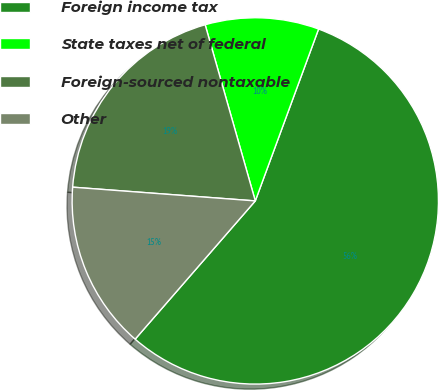Convert chart. <chart><loc_0><loc_0><loc_500><loc_500><pie_chart><fcel>Foreign income tax<fcel>State taxes net of federal<fcel>Foreign-sourced nontaxable<fcel>Other<nl><fcel>55.77%<fcel>10.03%<fcel>19.39%<fcel>14.81%<nl></chart> 